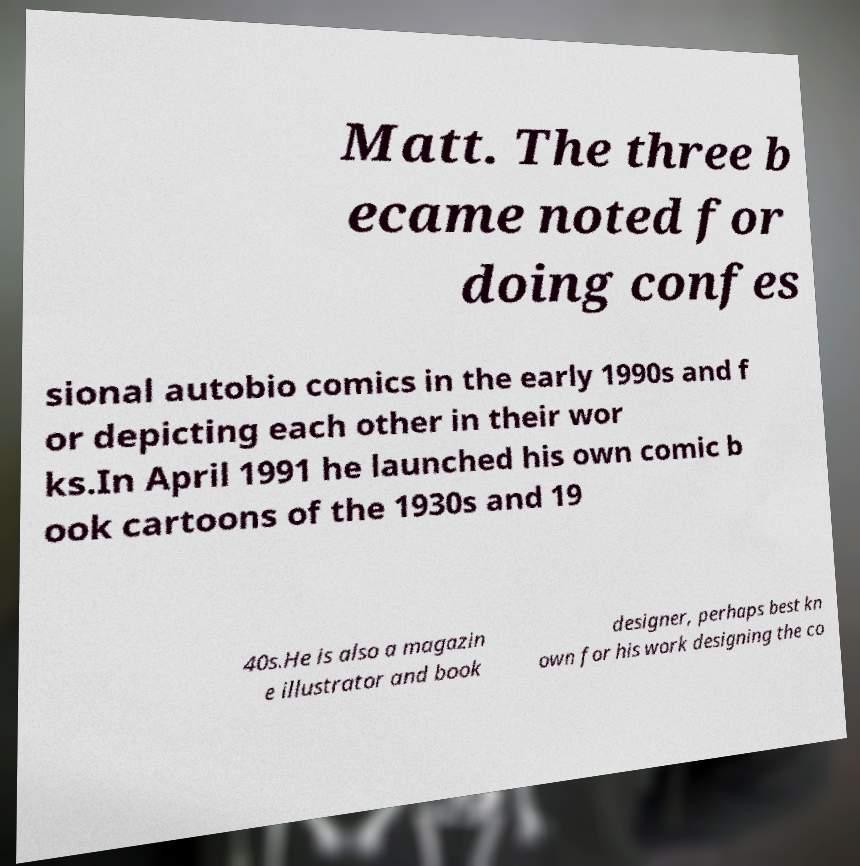Could you assist in decoding the text presented in this image and type it out clearly? Matt. The three b ecame noted for doing confes sional autobio comics in the early 1990s and f or depicting each other in their wor ks.In April 1991 he launched his own comic b ook cartoons of the 1930s and 19 40s.He is also a magazin e illustrator and book designer, perhaps best kn own for his work designing the co 